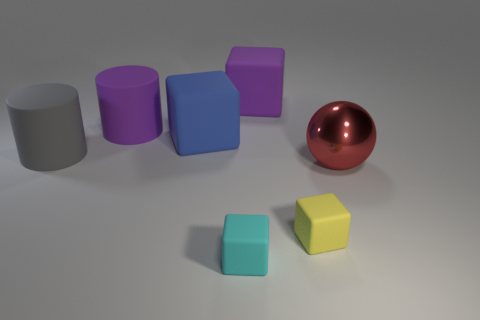Are there any other things that have the same material as the large sphere?
Provide a short and direct response. No. What shape is the tiny matte object behind the small matte block that is left of the block that is behind the large blue cube?
Offer a terse response. Cube. Is the big cube that is behind the large purple cylinder made of the same material as the large purple thing to the left of the cyan rubber cube?
Your answer should be very brief. Yes. What shape is the tiny yellow object that is the same material as the purple block?
Your response must be concise. Cube. Are there any other things that are the same color as the metallic thing?
Give a very brief answer. No. What number of brown cylinders are there?
Your response must be concise. 0. There is a cylinder left of the large cylinder that is behind the gray rubber thing; what is it made of?
Make the answer very short. Rubber. There is a large block behind the big cube that is in front of the cylinder that is to the right of the large gray matte object; what is its color?
Ensure brevity in your answer.  Purple. How many metal things are the same size as the gray matte object?
Your answer should be compact. 1. Are there more large blocks to the right of the yellow rubber block than red things that are left of the large purple cube?
Offer a terse response. No. 